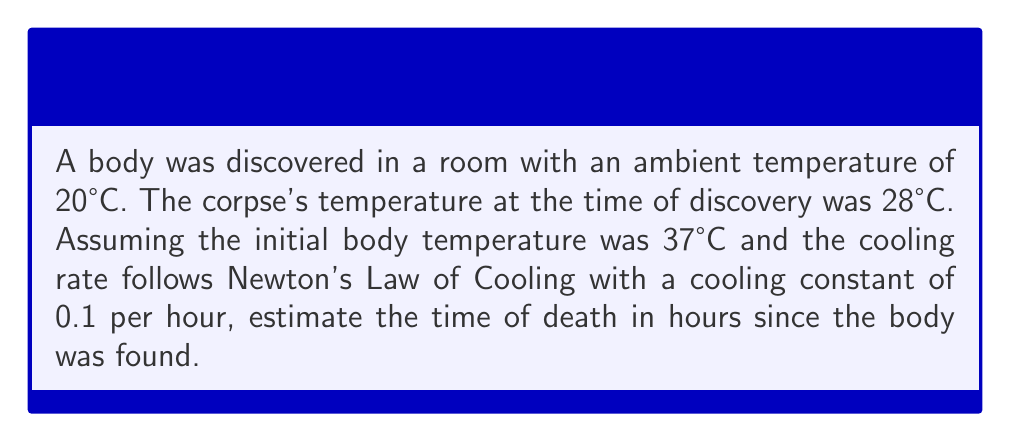Give your solution to this math problem. Let's approach this step-by-step using Newton's Law of Cooling:

1) The formula for Newton's Law of Cooling is:

   $$T(t) = T_s + (T_0 - T_s)e^{-kt}$$

   Where:
   $T(t)$ is the temperature at time $t$
   $T_s$ is the surrounding temperature
   $T_0$ is the initial temperature
   $k$ is the cooling constant
   $t$ is the time elapsed

2) We know:
   $T(t) = 28°C$ (current body temperature)
   $T_s = 20°C$ (ambient temperature)
   $T_0 = 37°C$ (initial body temperature)
   $k = 0.1$ per hour

3) Let's substitute these values into the equation:

   $$28 = 20 + (37 - 20)e^{-0.1t}$$

4) Simplify:
   $$28 = 20 + 17e^{-0.1t}$$
   $$8 = 17e^{-0.1t}$$

5) Divide both sides by 17:
   $$\frac{8}{17} = e^{-0.1t}$$

6) Take the natural log of both sides:
   $$\ln(\frac{8}{17}) = -0.1t$$

7) Solve for $t$:
   $$t = -\frac{\ln(\frac{8}{17})}{0.1} \approx 7.55$$

Therefore, the estimated time of death is approximately 7.55 hours before the body was found.
Answer: 7.55 hours 